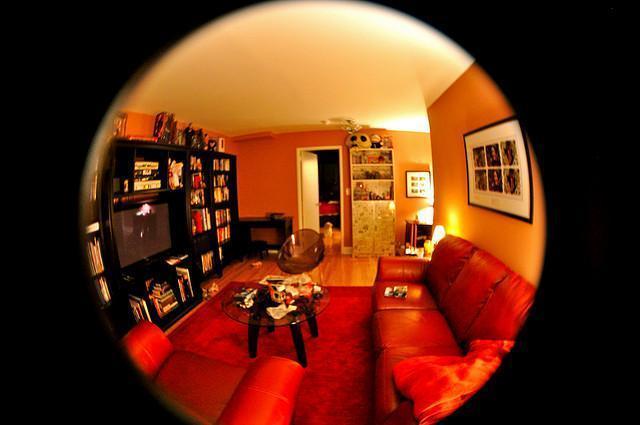How many couches can be seen?
Give a very brief answer. 2. 